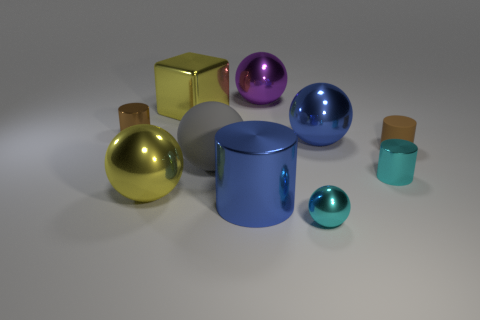The blue object that is the same shape as the big gray rubber thing is what size?
Ensure brevity in your answer.  Large. There is a small metal ball; does it have the same color as the small metallic cylinder on the right side of the big yellow metal sphere?
Your answer should be very brief. Yes. What is the size of the shiny sphere that is the same color as the large shiny cylinder?
Keep it short and to the point. Large. Are there more blue metallic objects that are on the left side of the large purple sphere than red matte cylinders?
Your answer should be compact. Yes. The other shiny cylinder that is the same size as the cyan shiny cylinder is what color?
Your answer should be compact. Brown. What number of objects are metal things behind the yellow metallic block or cyan rubber blocks?
Offer a very short reply. 1. The metallic object that is the same color as the metallic cube is what shape?
Your answer should be compact. Sphere. There is a brown thing that is in front of the small metallic object that is behind the big gray object; what is its material?
Provide a succinct answer. Rubber. Is there a red sphere made of the same material as the blue ball?
Ensure brevity in your answer.  No. There is a small brown cylinder left of the small rubber cylinder; is there a big cylinder that is on the right side of it?
Give a very brief answer. Yes. 